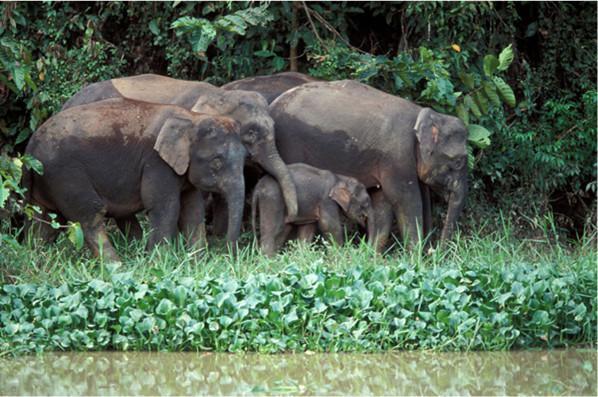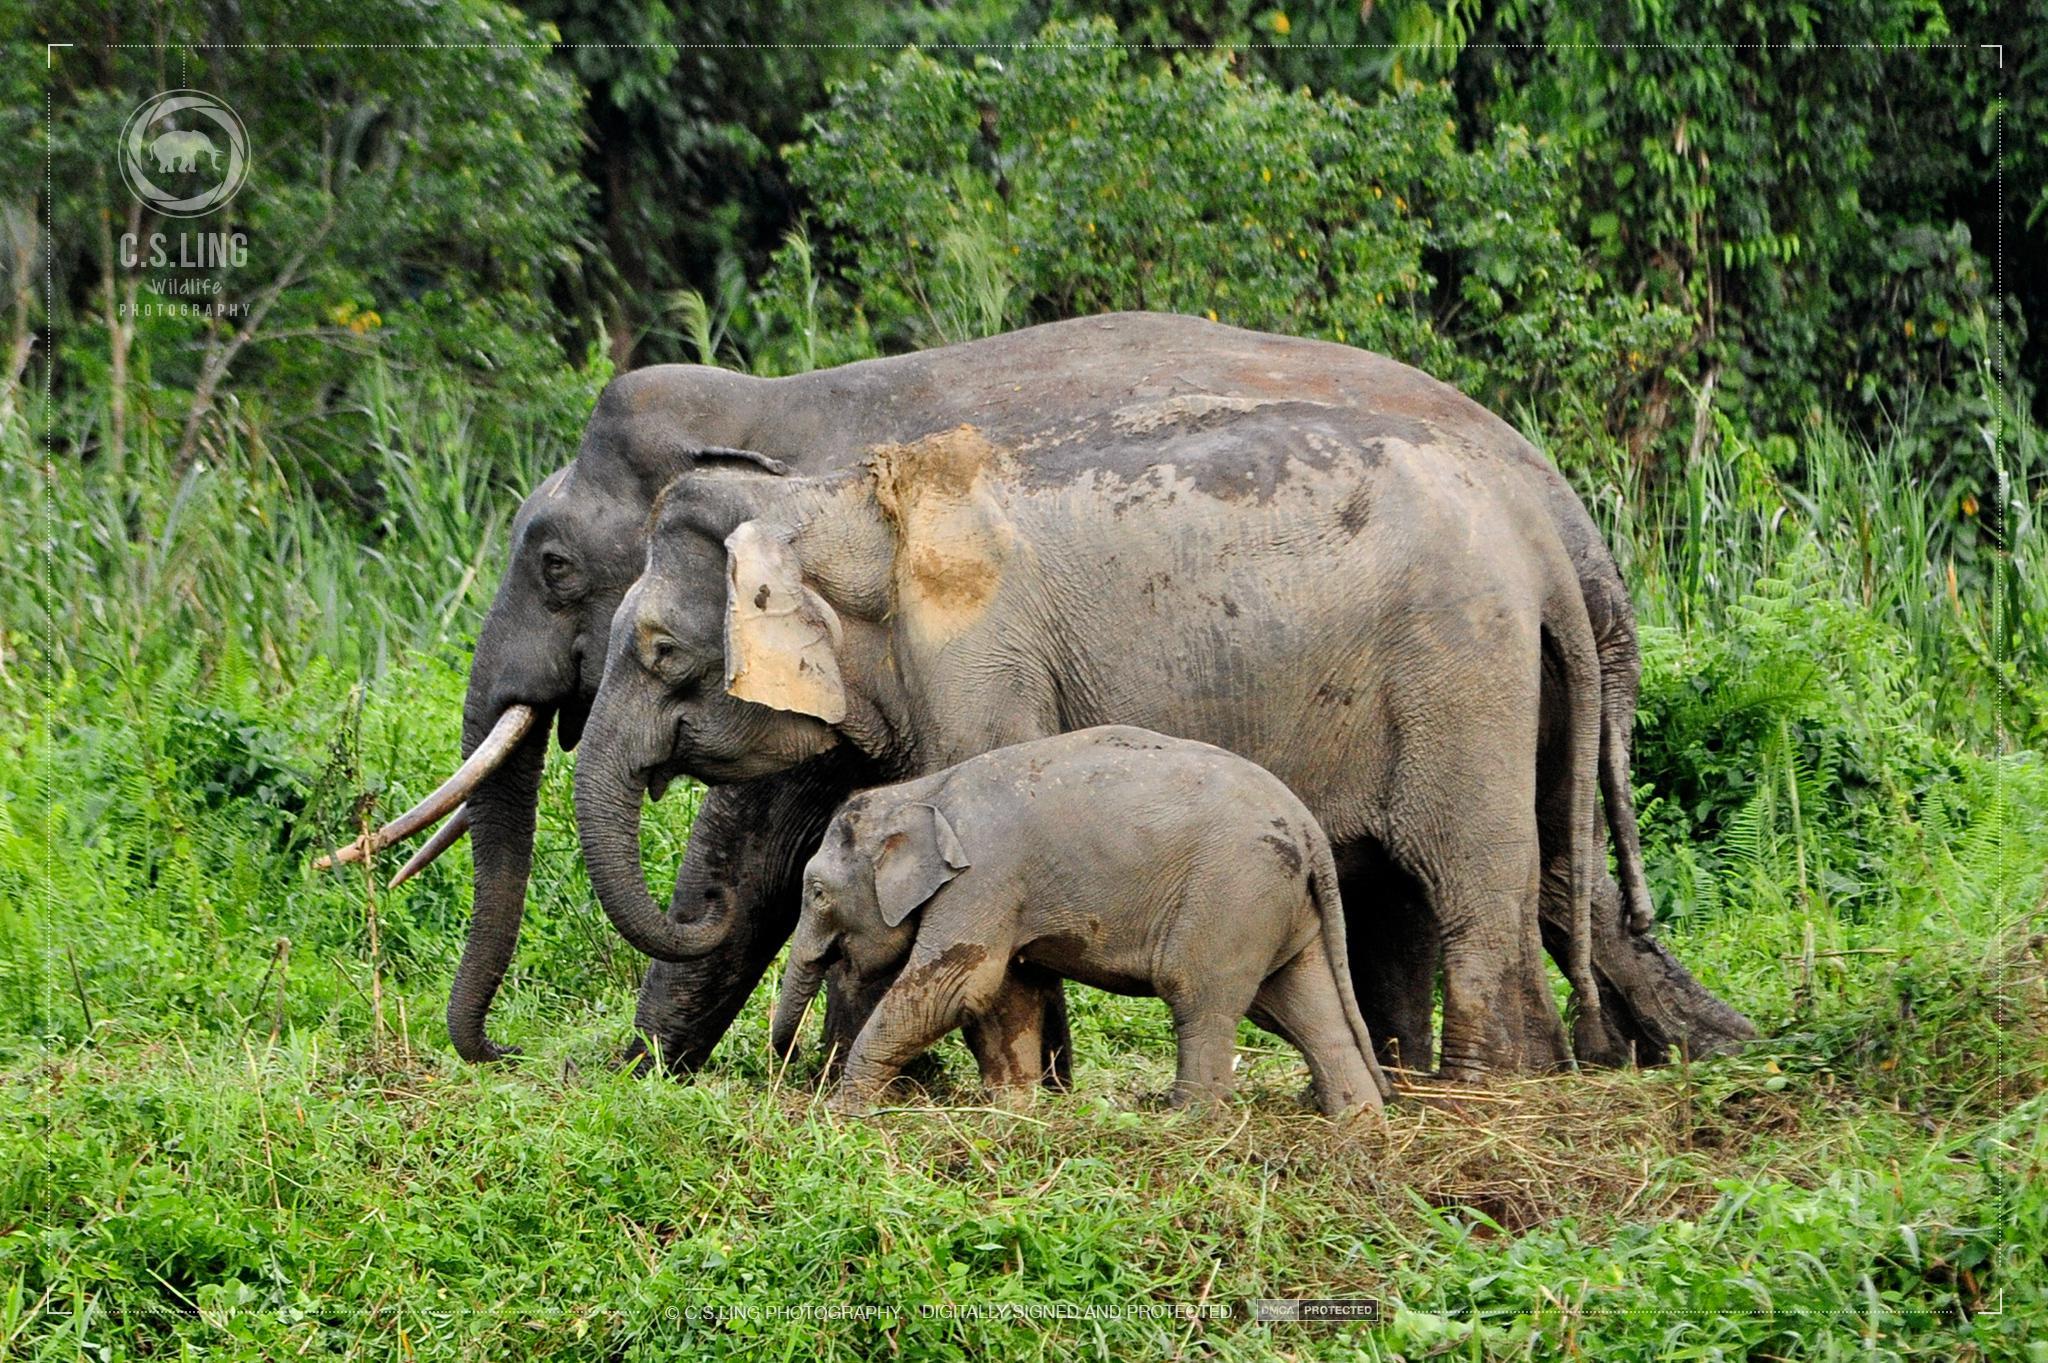The first image is the image on the left, the second image is the image on the right. Examine the images to the left and right. Is the description "Elephants are interacting with water." accurate? Answer yes or no. No. 